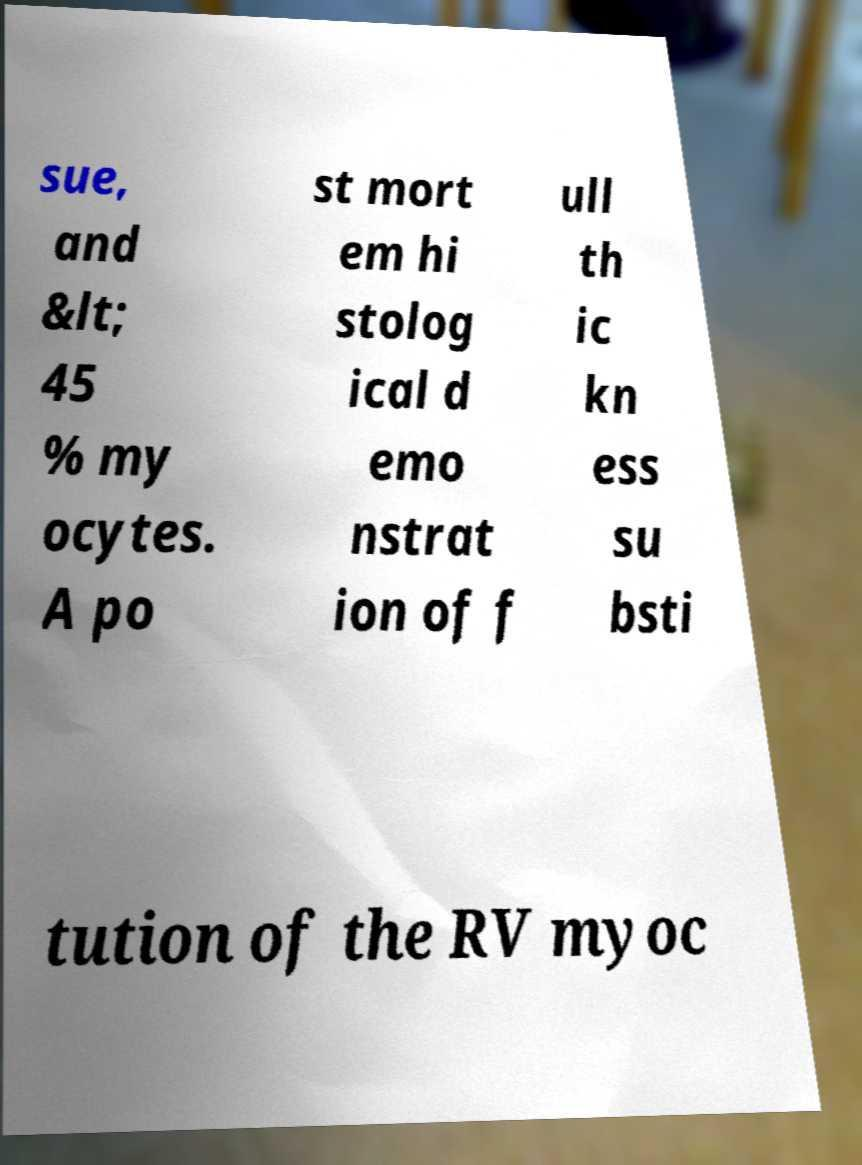For documentation purposes, I need the text within this image transcribed. Could you provide that? sue, and &lt; 45 % my ocytes. A po st mort em hi stolog ical d emo nstrat ion of f ull th ic kn ess su bsti tution of the RV myoc 